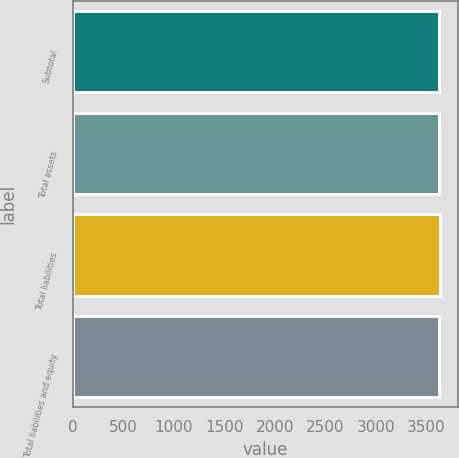Convert chart. <chart><loc_0><loc_0><loc_500><loc_500><bar_chart><fcel>Subtotal<fcel>Total assets<fcel>Total liabilities<fcel>Total liabilities and equity<nl><fcel>3630<fcel>3630.4<fcel>3634<fcel>3630.8<nl></chart> 